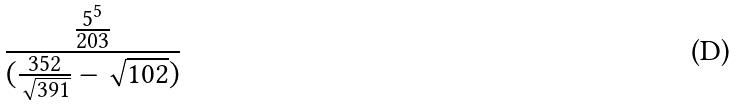<formula> <loc_0><loc_0><loc_500><loc_500>\frac { \frac { 5 ^ { 5 } } { 2 0 3 } } { ( \frac { 3 5 2 } { \sqrt { 3 9 1 } } - \sqrt { 1 0 2 } ) }</formula> 